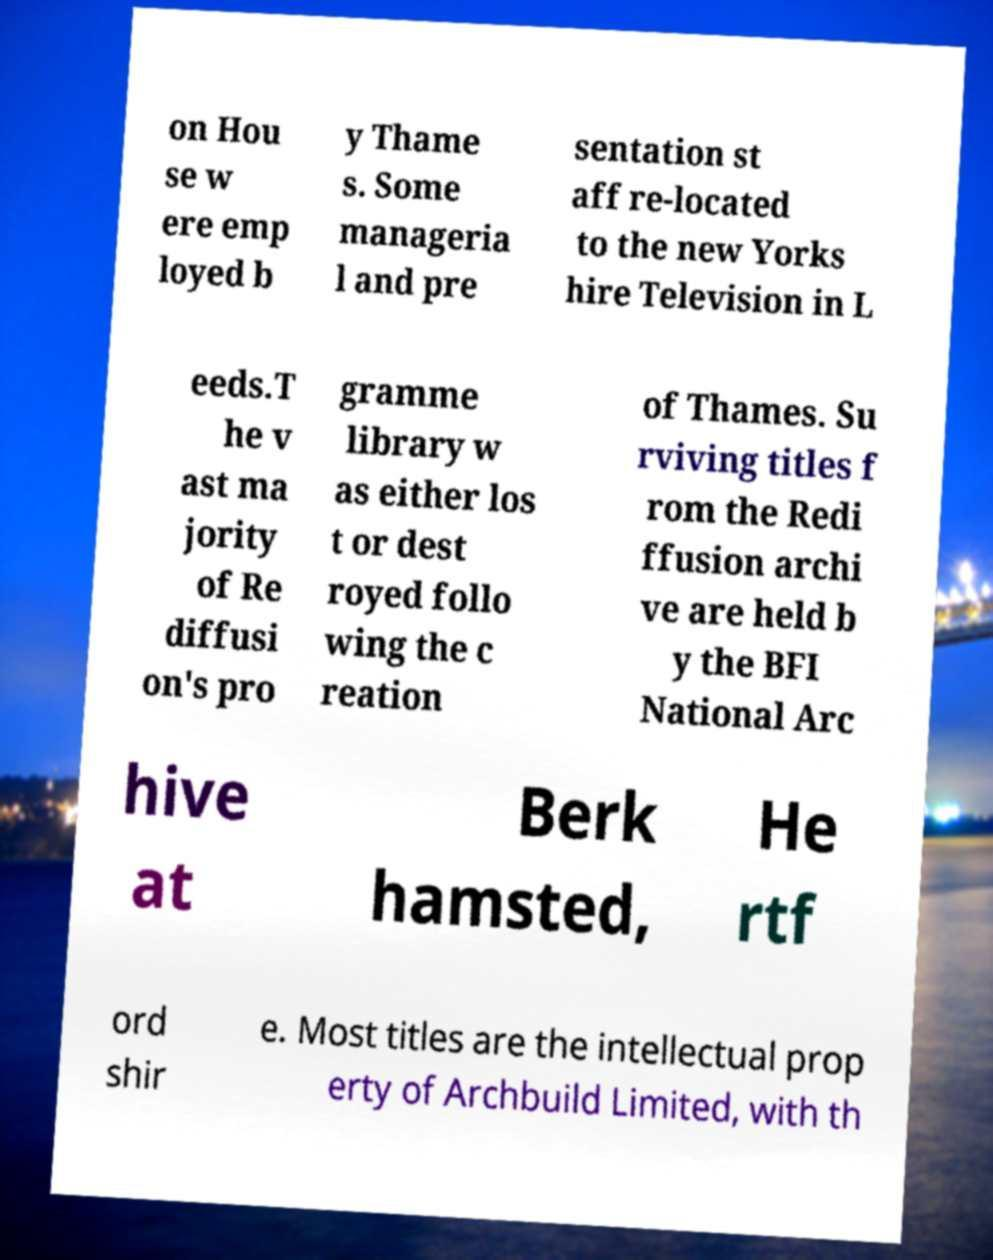What messages or text are displayed in this image? I need them in a readable, typed format. on Hou se w ere emp loyed b y Thame s. Some manageria l and pre sentation st aff re-located to the new Yorks hire Television in L eeds.T he v ast ma jority of Re diffusi on's pro gramme library w as either los t or dest royed follo wing the c reation of Thames. Su rviving titles f rom the Redi ffusion archi ve are held b y the BFI National Arc hive at Berk hamsted, He rtf ord shir e. Most titles are the intellectual prop erty of Archbuild Limited, with th 